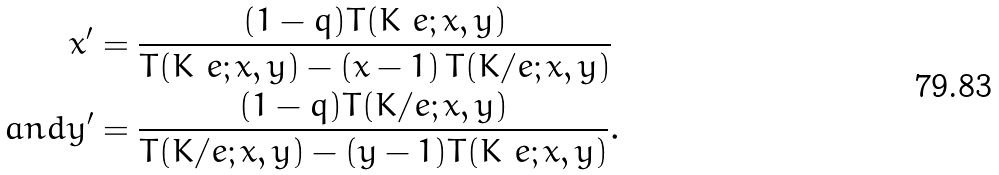Convert formula to latex. <formula><loc_0><loc_0><loc_500><loc_500>x ^ { \prime } & = \frac { ( 1 - q ) T ( K \ e ; x , y ) } { T ( K \ e ; x , y ) - ( x - 1 ) \, T ( K / e ; x , y ) } \\ { a n d } y ^ { \prime } & = \frac { ( 1 - q ) T ( K / e ; x , y ) } { T ( K / e ; x , y ) - ( y - 1 ) T ( K \ e ; x , y ) } .</formula> 